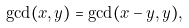Convert formula to latex. <formula><loc_0><loc_0><loc_500><loc_500>\gcd ( x , y ) = \gcd ( x - y , y ) ,</formula> 